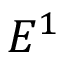<formula> <loc_0><loc_0><loc_500><loc_500>E ^ { 1 }</formula> 